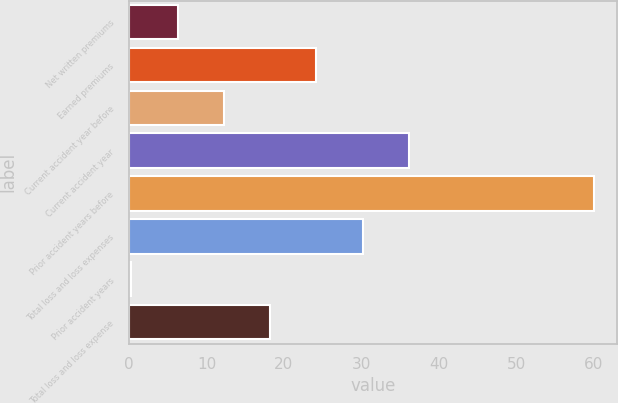<chart> <loc_0><loc_0><loc_500><loc_500><bar_chart><fcel>Net written premiums<fcel>Earned premiums<fcel>Current accident year before<fcel>Current accident year<fcel>Prior accident years before<fcel>Total loss and loss expenses<fcel>Prior accident years<fcel>Total loss and loss expense<nl><fcel>6.27<fcel>24.18<fcel>12.24<fcel>36.12<fcel>60<fcel>30.15<fcel>0.3<fcel>18.21<nl></chart> 